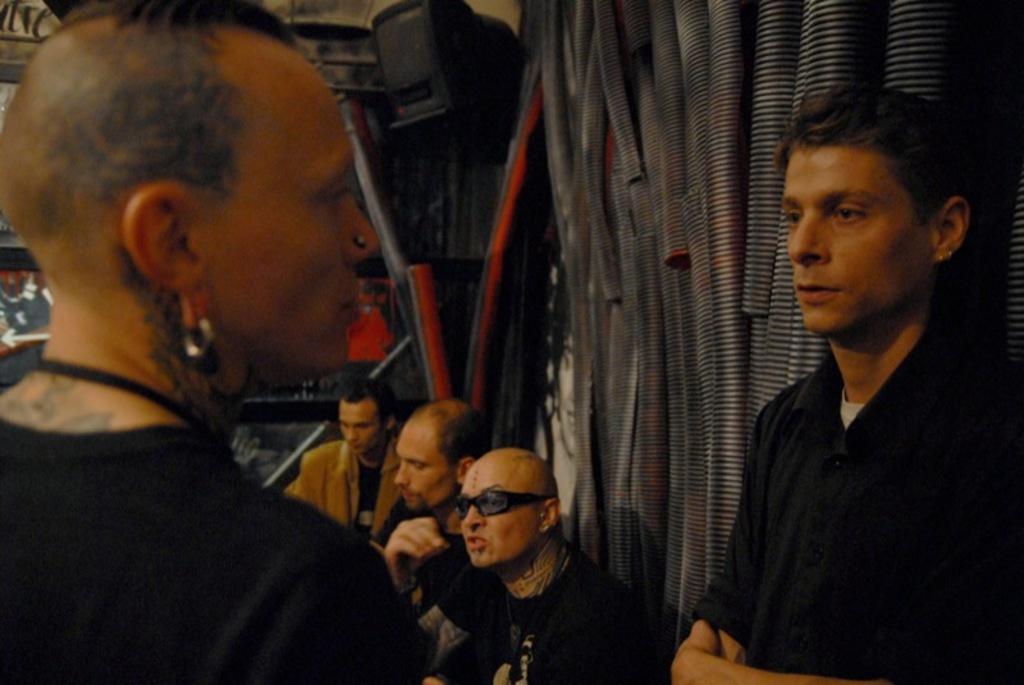How would you summarize this image in a sentence or two? In the image there are two persons standing in front of each other in black t-shirt and behind them there are pipes on the wall and three persons sitting. 